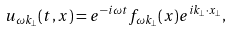Convert formula to latex. <formula><loc_0><loc_0><loc_500><loc_500>u _ { \omega k _ { \perp } } ( t , x ) = e ^ { - i \omega t } f _ { \omega k _ { \perp } } ( x ) e ^ { i k _ { \perp } \cdot x _ { \perp } } ,</formula> 